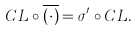<formula> <loc_0><loc_0><loc_500><loc_500>C L \circ \overline { ( \cdot ) } = \sigma ^ { \prime } \circ C L .</formula> 